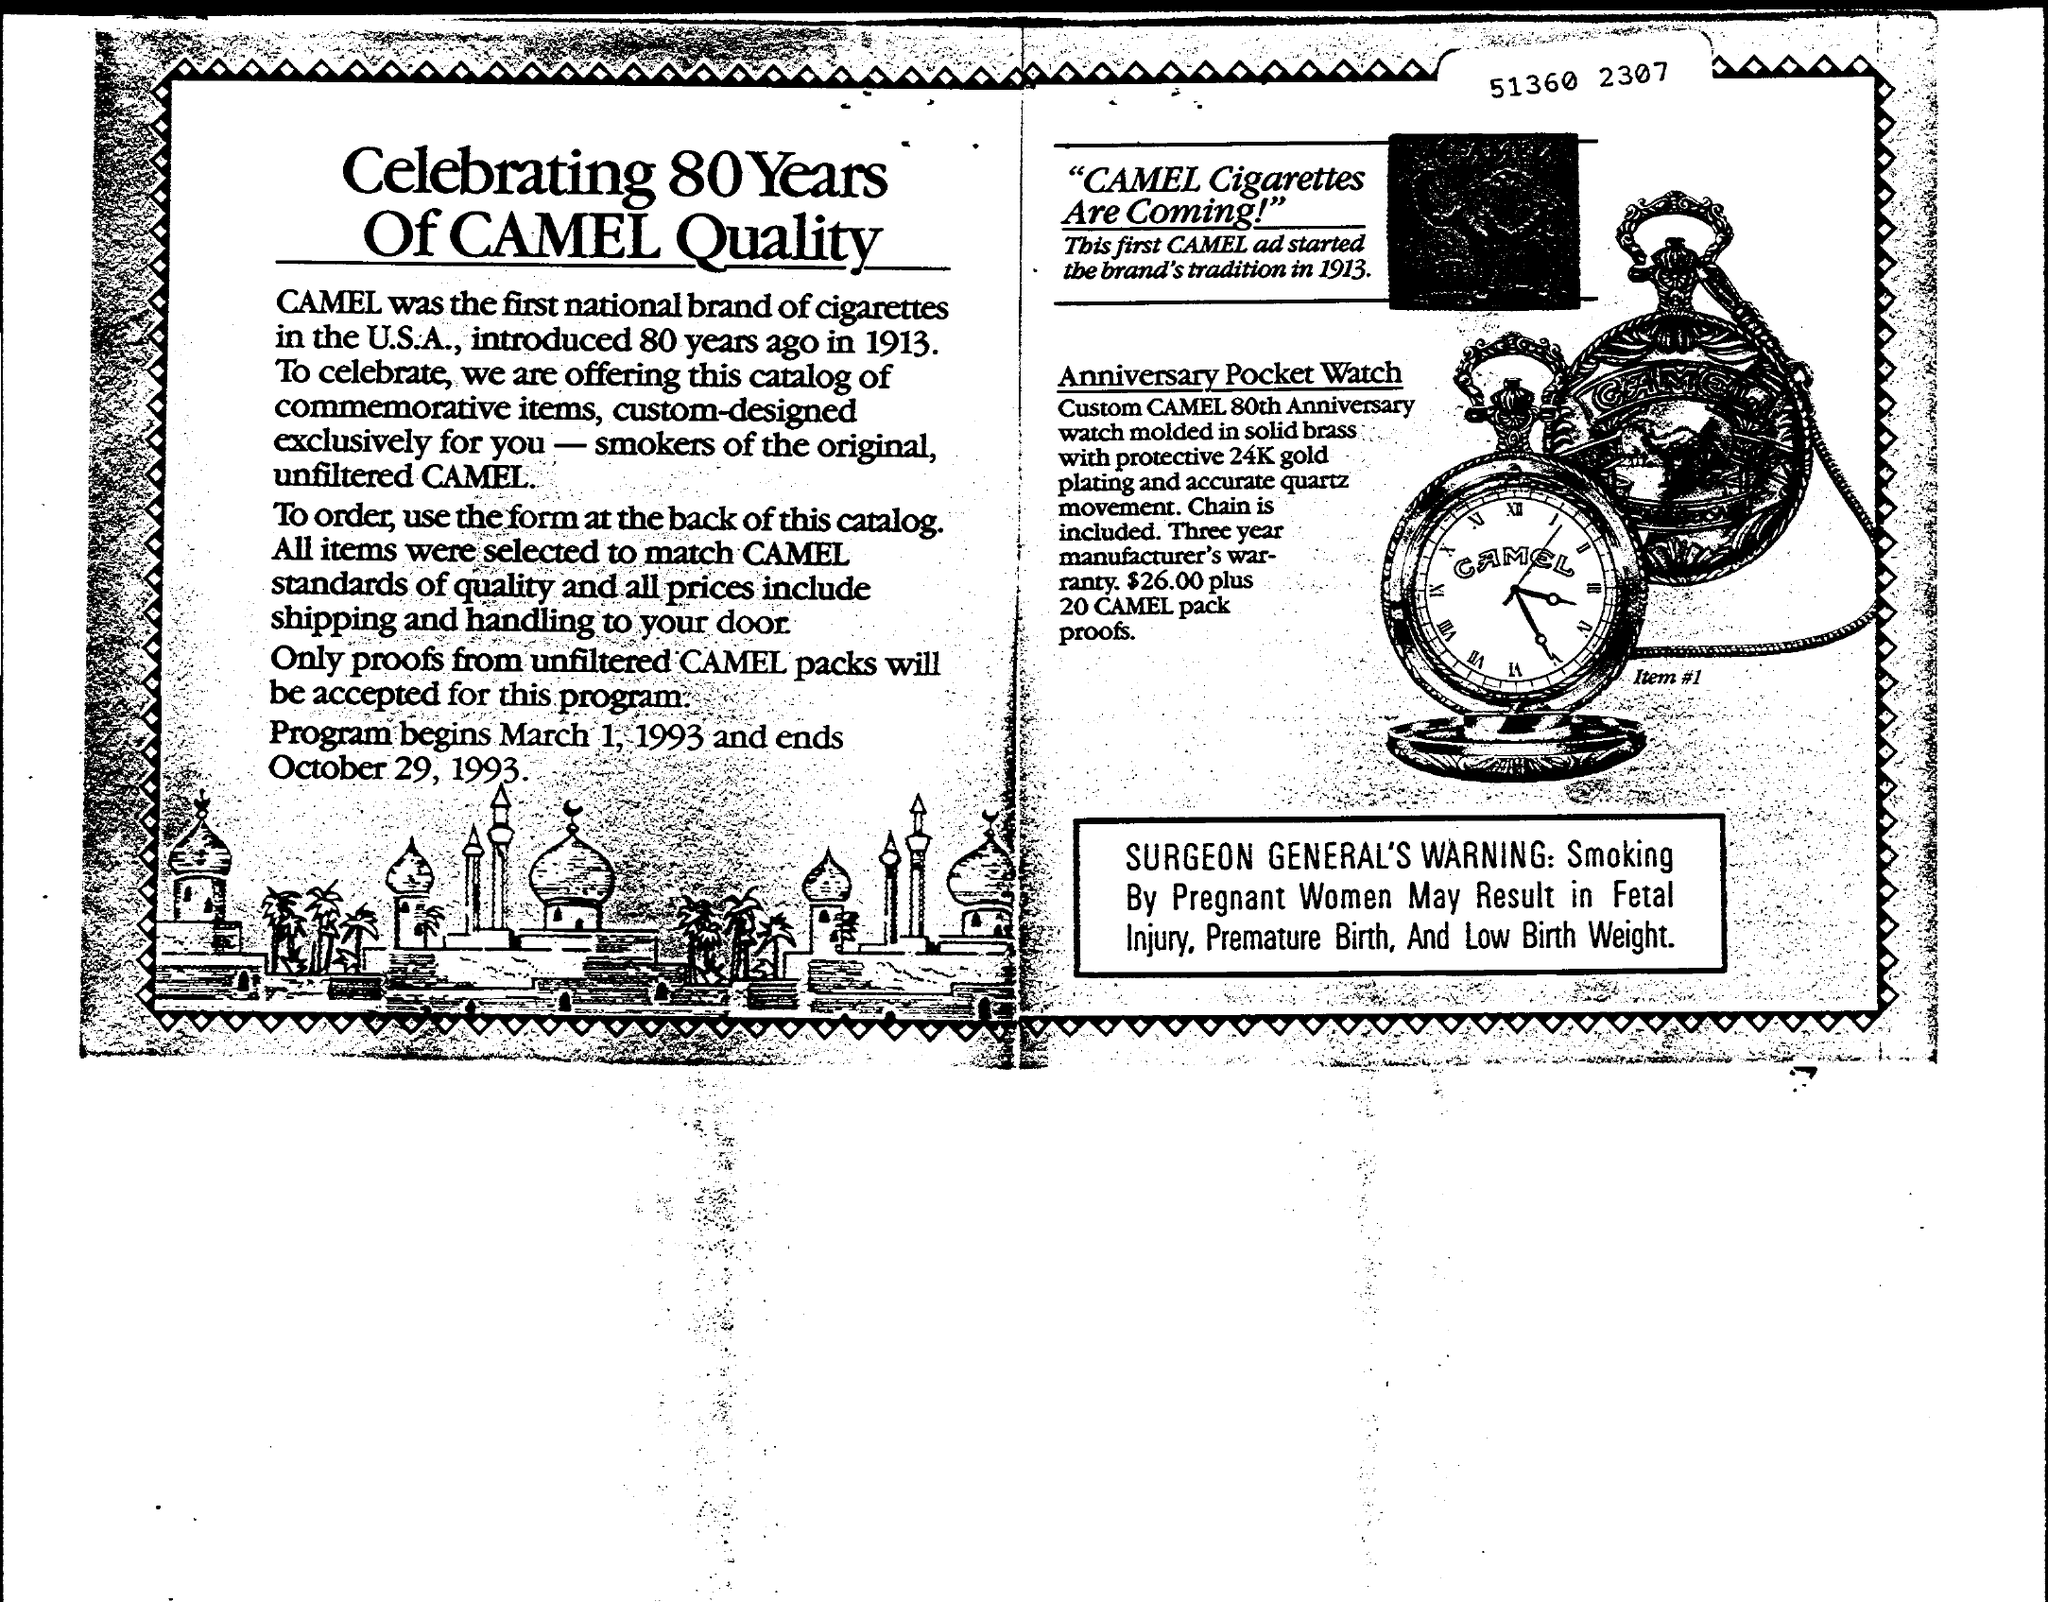Draw attention to some important aspects in this diagram. The program began on March 1, 1993. Camel was the first national brand of cigarettes in the United States. Camels were introduced 80 years ago, in 1913. 